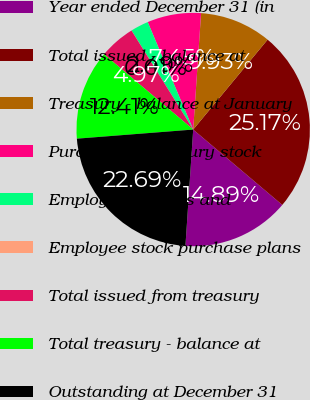Convert chart to OTSL. <chart><loc_0><loc_0><loc_500><loc_500><pie_chart><fcel>Year ended December 31 (in<fcel>Total issued - balance at<fcel>Treasury - balance at January<fcel>Purchase of treasury stock<fcel>Employee benefits and<fcel>Employee stock purchase plans<fcel>Total issued from treasury<fcel>Total treasury - balance at<fcel>Outstanding at December 31<nl><fcel>14.89%<fcel>25.18%<fcel>9.93%<fcel>7.45%<fcel>2.49%<fcel>0.01%<fcel>4.97%<fcel>12.41%<fcel>22.7%<nl></chart> 